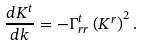<formula> <loc_0><loc_0><loc_500><loc_500>\frac { d K ^ { t } } { d k } = - \Gamma _ { r r } ^ { t } \left ( K ^ { r } \right ) ^ { 2 } .</formula> 